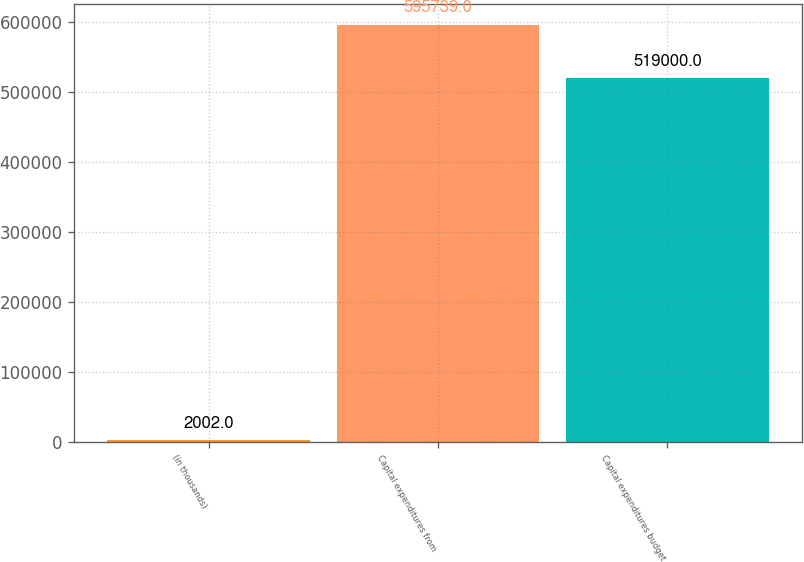Convert chart. <chart><loc_0><loc_0><loc_500><loc_500><bar_chart><fcel>(in thousands)<fcel>Capital expenditures from<fcel>Capital expenditures budget<nl><fcel>2002<fcel>595739<fcel>519000<nl></chart> 